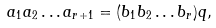<formula> <loc_0><loc_0><loc_500><loc_500>a _ { 1 } a _ { 2 } \dots a _ { r + 1 } = ( b _ { 1 } b _ { 2 } \dots b _ { r } ) q ,</formula> 